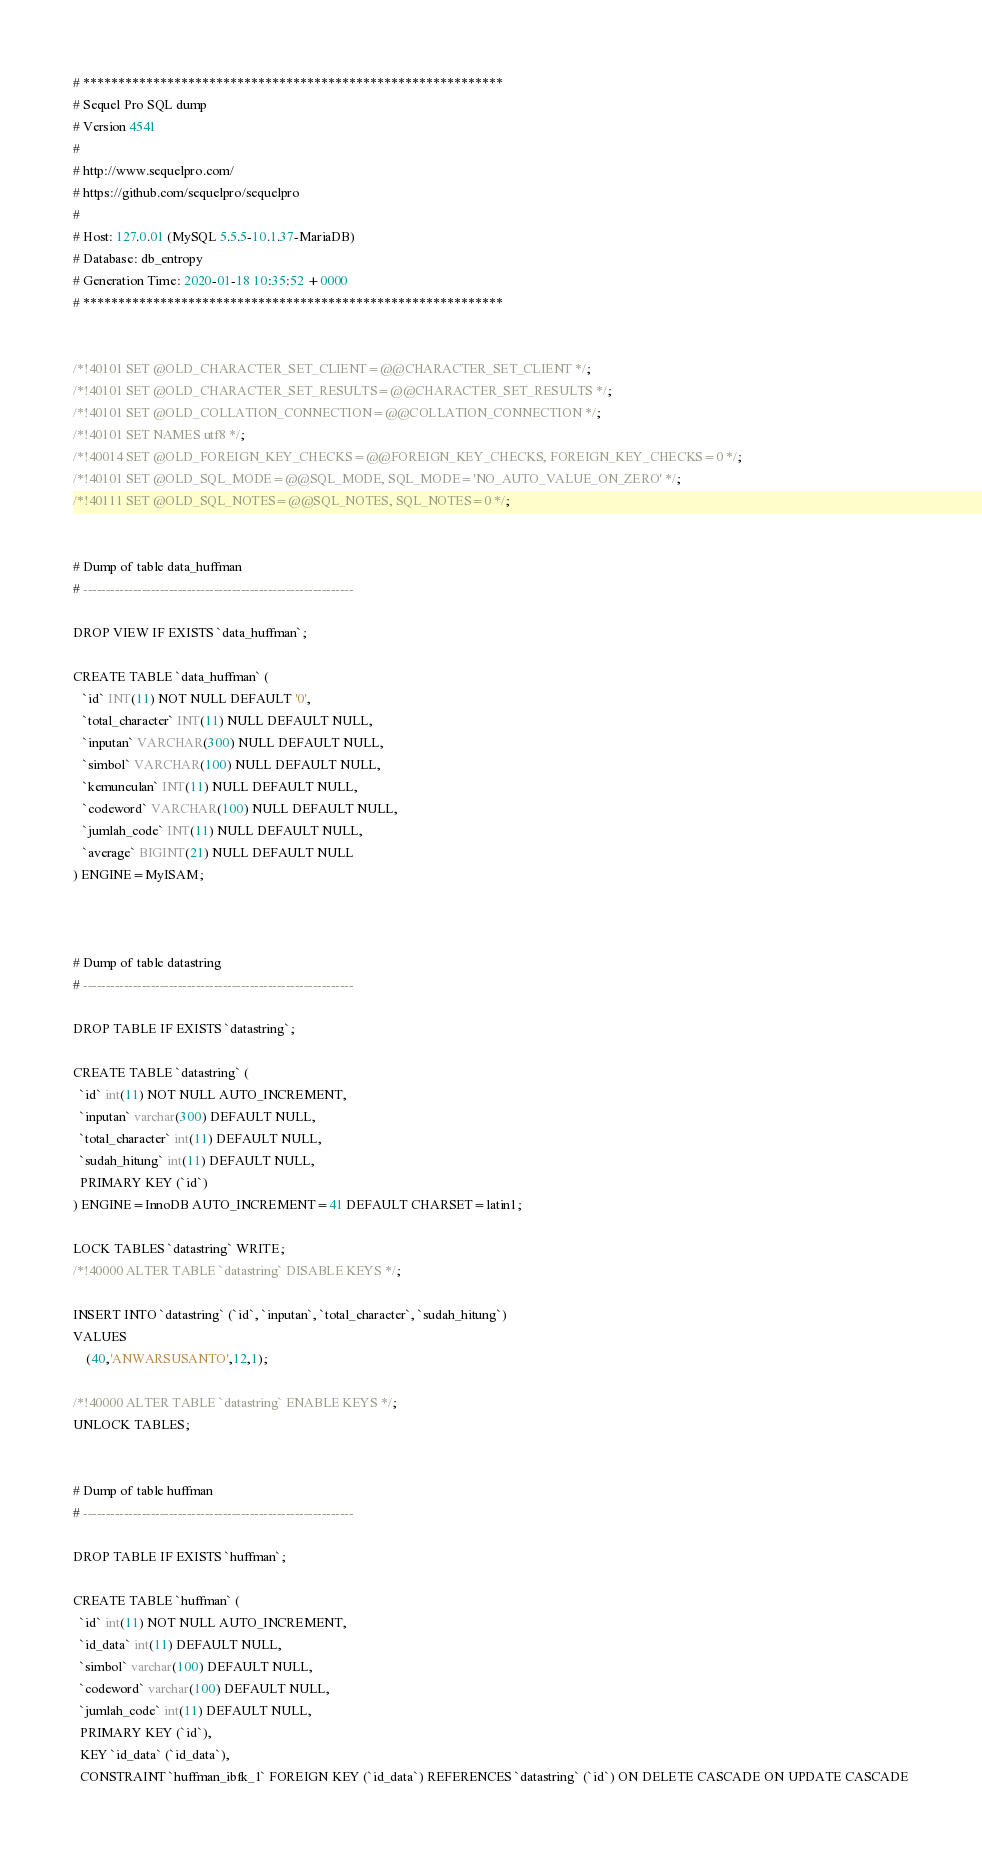<code> <loc_0><loc_0><loc_500><loc_500><_SQL_># ************************************************************
# Sequel Pro SQL dump
# Version 4541
#
# http://www.sequelpro.com/
# https://github.com/sequelpro/sequelpro
#
# Host: 127.0.01 (MySQL 5.5.5-10.1.37-MariaDB)
# Database: db_entropy
# Generation Time: 2020-01-18 10:35:52 +0000
# ************************************************************


/*!40101 SET @OLD_CHARACTER_SET_CLIENT=@@CHARACTER_SET_CLIENT */;
/*!40101 SET @OLD_CHARACTER_SET_RESULTS=@@CHARACTER_SET_RESULTS */;
/*!40101 SET @OLD_COLLATION_CONNECTION=@@COLLATION_CONNECTION */;
/*!40101 SET NAMES utf8 */;
/*!40014 SET @OLD_FOREIGN_KEY_CHECKS=@@FOREIGN_KEY_CHECKS, FOREIGN_KEY_CHECKS=0 */;
/*!40101 SET @OLD_SQL_MODE=@@SQL_MODE, SQL_MODE='NO_AUTO_VALUE_ON_ZERO' */;
/*!40111 SET @OLD_SQL_NOTES=@@SQL_NOTES, SQL_NOTES=0 */;


# Dump of table data_huffman
# ------------------------------------------------------------

DROP VIEW IF EXISTS `data_huffman`;

CREATE TABLE `data_huffman` (
   `id` INT(11) NOT NULL DEFAULT '0',
   `total_character` INT(11) NULL DEFAULT NULL,
   `inputan` VARCHAR(300) NULL DEFAULT NULL,
   `simbol` VARCHAR(100) NULL DEFAULT NULL,
   `kemunculan` INT(11) NULL DEFAULT NULL,
   `codeword` VARCHAR(100) NULL DEFAULT NULL,
   `jumlah_code` INT(11) NULL DEFAULT NULL,
   `average` BIGINT(21) NULL DEFAULT NULL
) ENGINE=MyISAM;



# Dump of table datastring
# ------------------------------------------------------------

DROP TABLE IF EXISTS `datastring`;

CREATE TABLE `datastring` (
  `id` int(11) NOT NULL AUTO_INCREMENT,
  `inputan` varchar(300) DEFAULT NULL,
  `total_character` int(11) DEFAULT NULL,
  `sudah_hitung` int(11) DEFAULT NULL,
  PRIMARY KEY (`id`)
) ENGINE=InnoDB AUTO_INCREMENT=41 DEFAULT CHARSET=latin1;

LOCK TABLES `datastring` WRITE;
/*!40000 ALTER TABLE `datastring` DISABLE KEYS */;

INSERT INTO `datastring` (`id`, `inputan`, `total_character`, `sudah_hitung`)
VALUES
	(40,'ANWARSUSANTO',12,1);

/*!40000 ALTER TABLE `datastring` ENABLE KEYS */;
UNLOCK TABLES;


# Dump of table huffman
# ------------------------------------------------------------

DROP TABLE IF EXISTS `huffman`;

CREATE TABLE `huffman` (
  `id` int(11) NOT NULL AUTO_INCREMENT,
  `id_data` int(11) DEFAULT NULL,
  `simbol` varchar(100) DEFAULT NULL,
  `codeword` varchar(100) DEFAULT NULL,
  `jumlah_code` int(11) DEFAULT NULL,
  PRIMARY KEY (`id`),
  KEY `id_data` (`id_data`),
  CONSTRAINT `huffman_ibfk_1` FOREIGN KEY (`id_data`) REFERENCES `datastring` (`id`) ON DELETE CASCADE ON UPDATE CASCADE</code> 